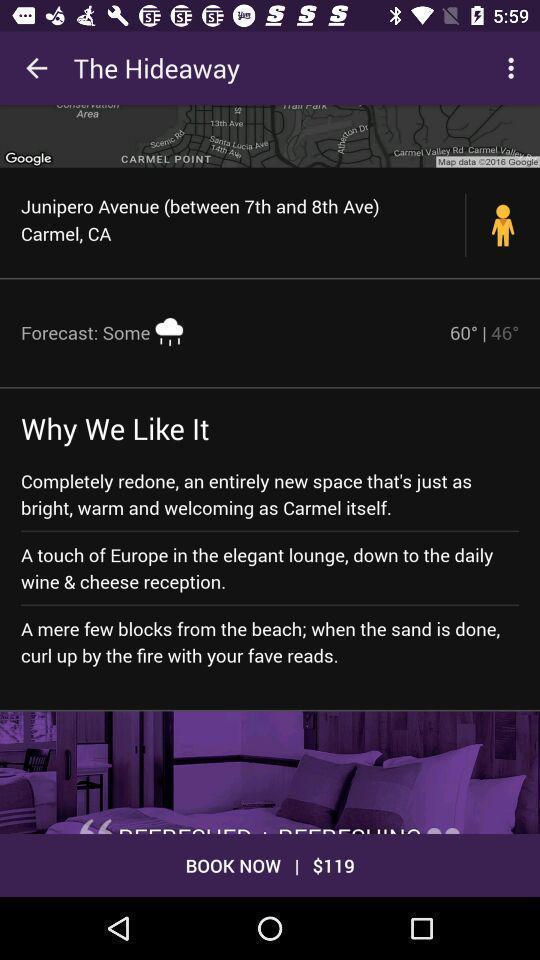Provide a detailed account of this screenshot. Page showing information and showing price for booking. 